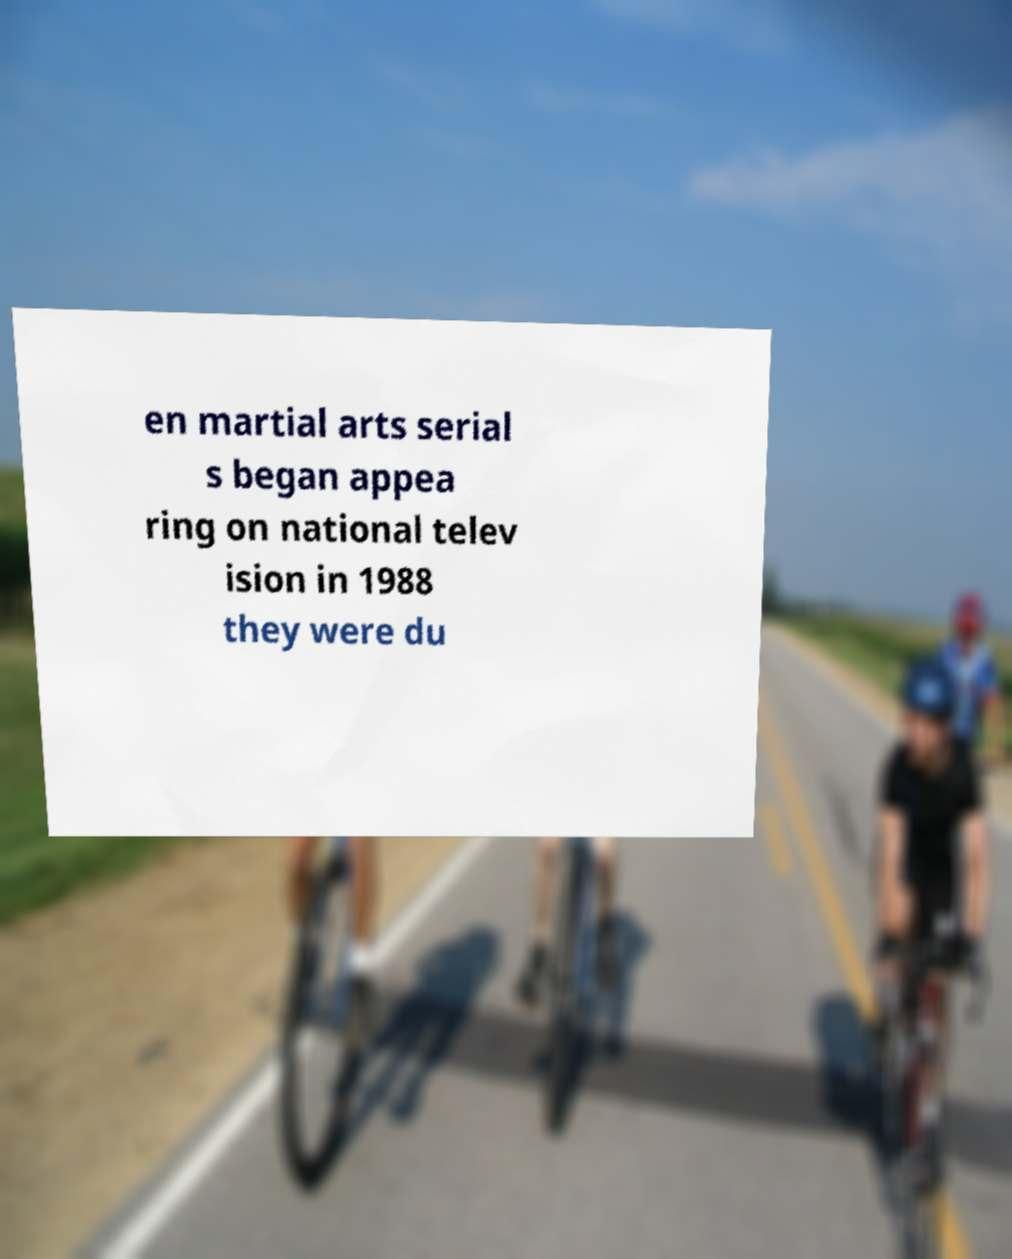Can you accurately transcribe the text from the provided image for me? en martial arts serial s began appea ring on national telev ision in 1988 they were du 